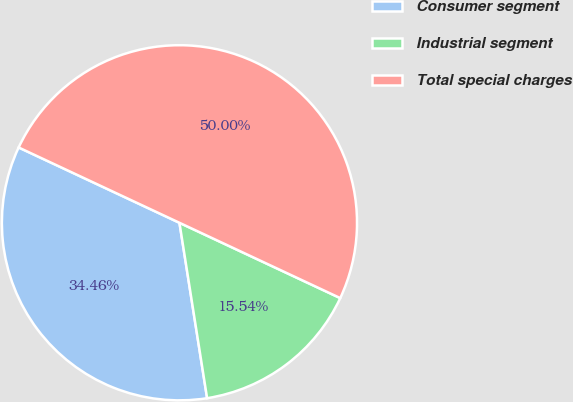Convert chart to OTSL. <chart><loc_0><loc_0><loc_500><loc_500><pie_chart><fcel>Consumer segment<fcel>Industrial segment<fcel>Total special charges<nl><fcel>34.46%<fcel>15.54%<fcel>50.0%<nl></chart> 